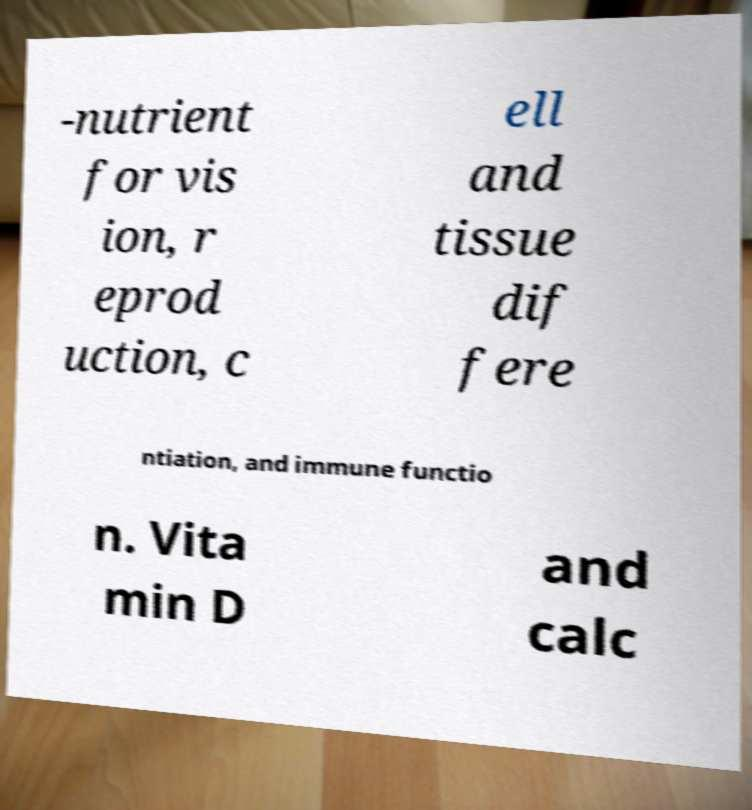There's text embedded in this image that I need extracted. Can you transcribe it verbatim? -nutrient for vis ion, r eprod uction, c ell and tissue dif fere ntiation, and immune functio n. Vita min D and calc 